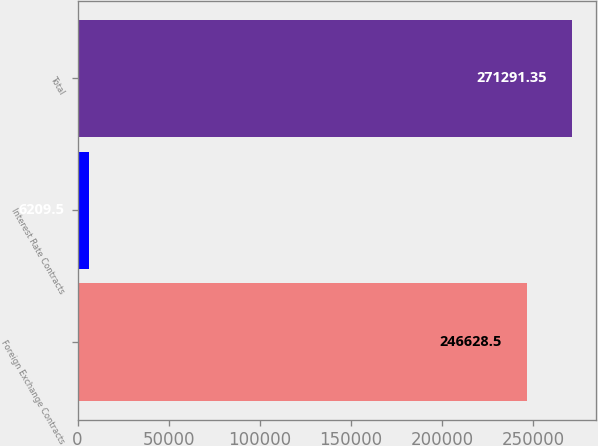Convert chart. <chart><loc_0><loc_0><loc_500><loc_500><bar_chart><fcel>Foreign Exchange Contracts<fcel>Interest Rate Contracts<fcel>Total<nl><fcel>246628<fcel>6209.5<fcel>271291<nl></chart> 